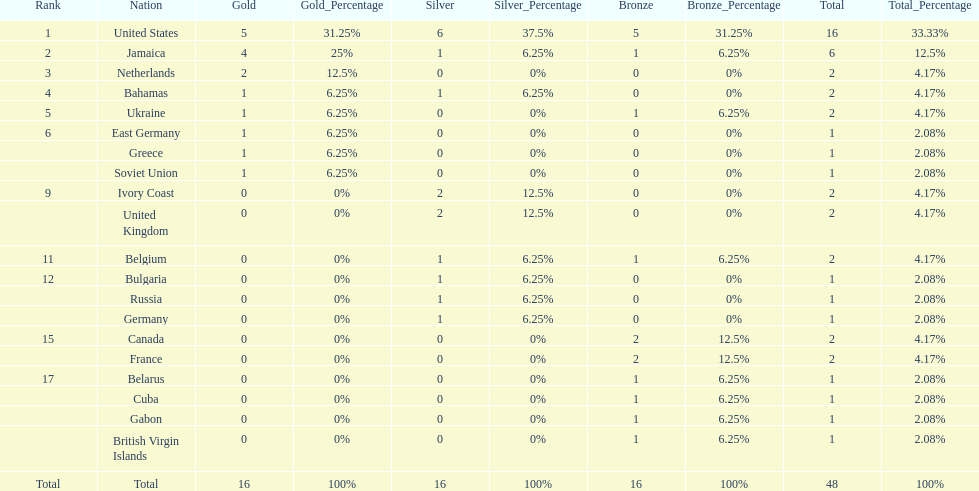What is the total number of gold medals won by jamaica? 4. 